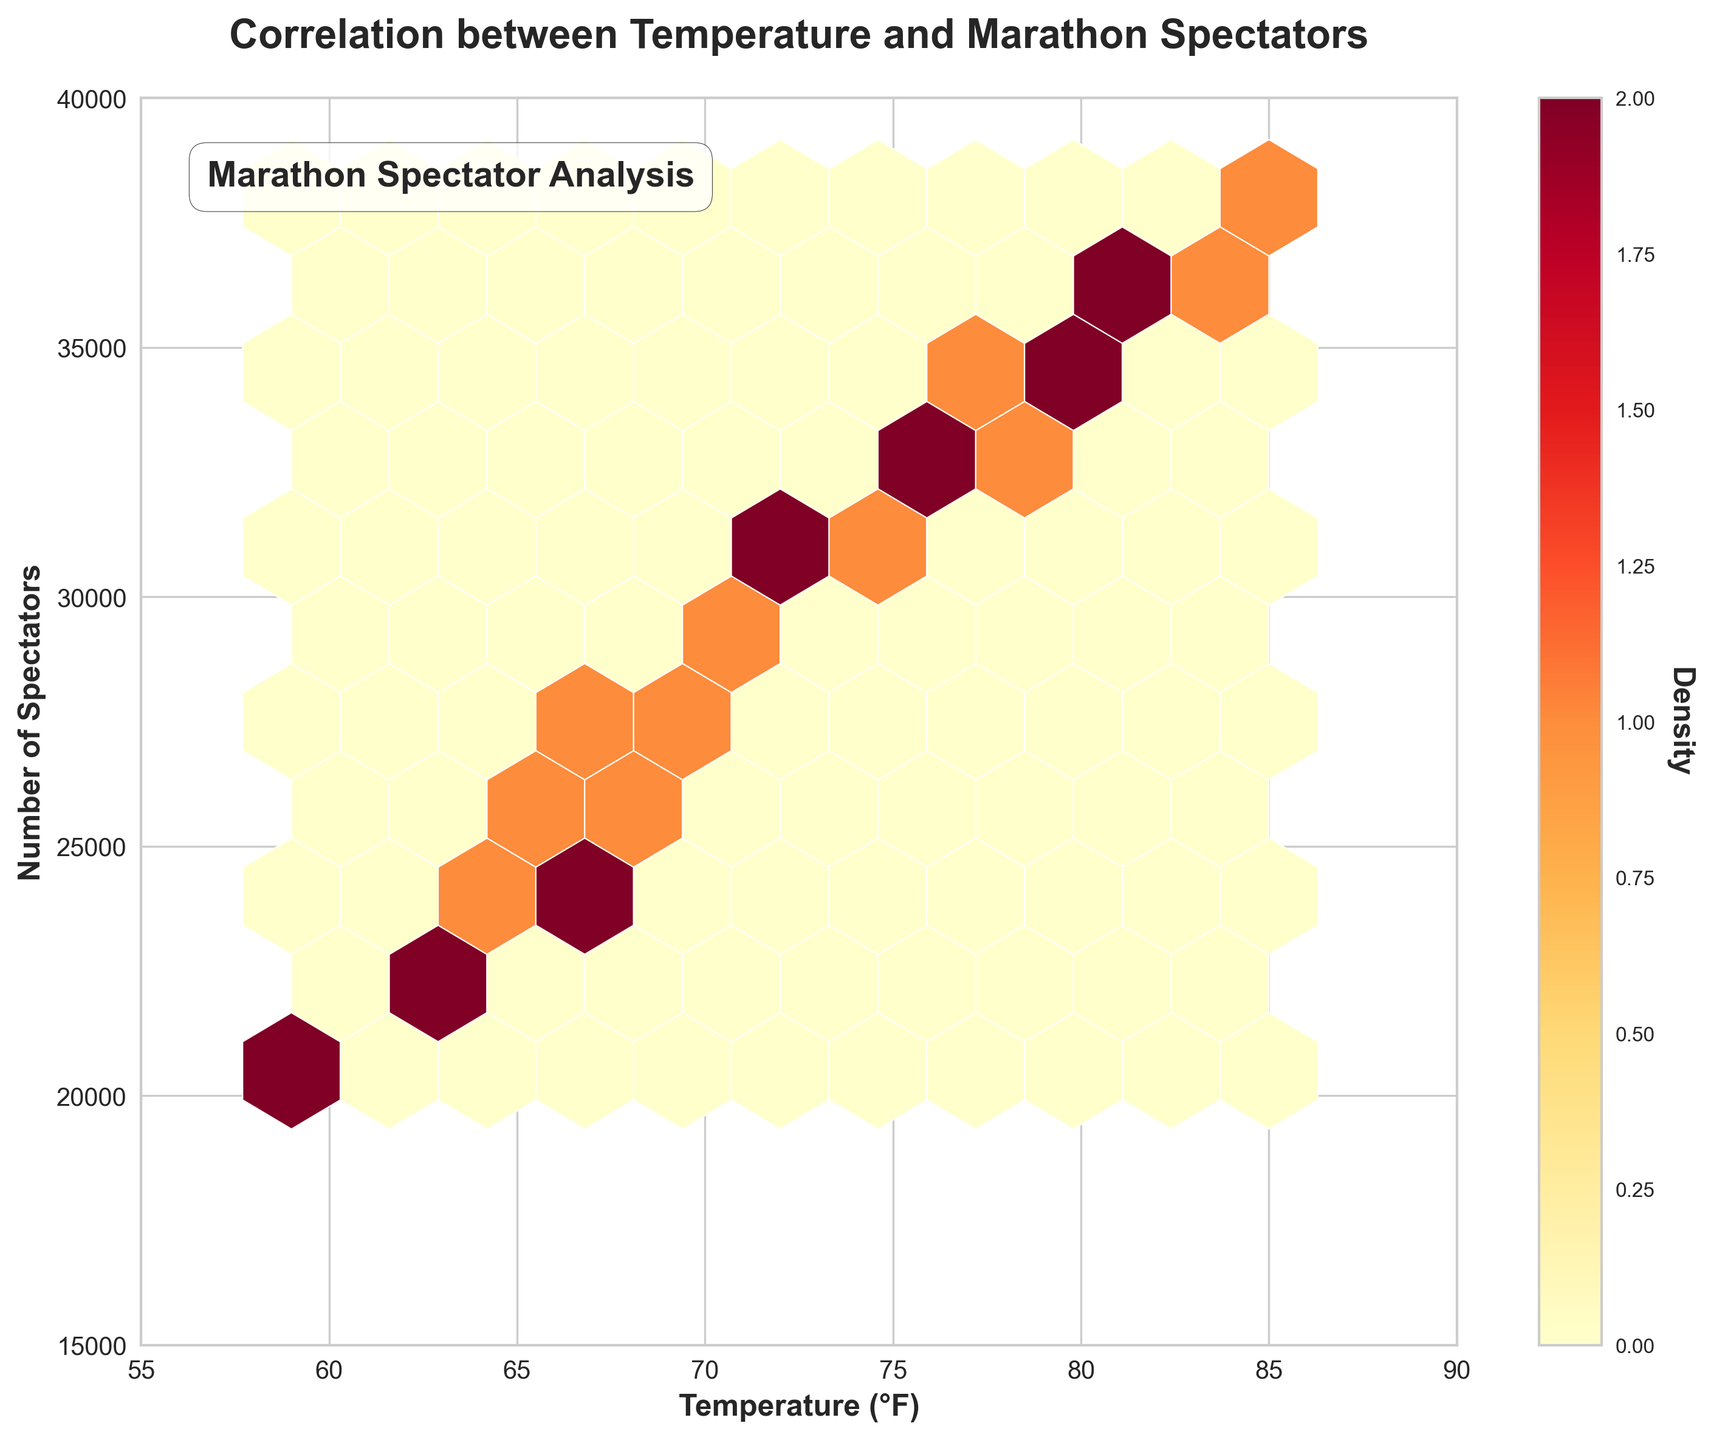What is the title of the plot? The title is prominently displayed at the top of the plot, which reads 'Correlation between Temperature and Marathon Spectators'.
Answer: Correlation between Temperature and Marathon Spectators What are the labels for the x and y axes? The labels can be found on each axis. The x-axis is labeled 'Temperature (°F)' and the y-axis is labeled 'Number of Spectators'.
Answer: Temperature (°F); Number of Spectators What is the range of temperatures displayed on the x-axis? The plot has clear axis limits. The x-axis shows temperatures ranging from 55 to 90 degrees Fahrenheit.
Answer: 55 to 90 What is the range for the number of spectators displayed on the y-axis? From the plot's y-axis limits, the number of spectators ranges from 15,000 to 40,000.
Answer: 15,000 to 40,000 In which temperature range is the highest density of spectators observed? By looking at the color intensity (densest part of the hexbin), it is visible around the mid-70s to low 80s in Fahrenheit.
Answer: Mid-70s to low 80s Is the density of spectators spread equally for all temperature ranges? Observing the variety in color intensity, it is clear that the density is not uniform. Higher densities are observed in specific temperature ranges.
Answer: No What is the general trend between temperature and the number of spectators? By analyzing the overall pattern of color intensities, there is a visible positive correlation—more spectators appear to attend as the temperature increases.
Answer: Positive correlation What range of temperatures has the least number of spectators? Observing the color with the least density, temperatures in the high 50s to low 60s have the least number of spectators.
Answer: High 50s to low 60s How does a density plot help in analyzing this type of data? The density plot, through color intensities, allows us to see where the data points are most densely populated and observe overall trends effectively.
Answer: Shows data point density and trends What additional information does the color bar provide in the plot? The color bar indicates the density of the data points, showing which areas have higher concentrations of spectators for given temperatures.
Answer: Density indicator 